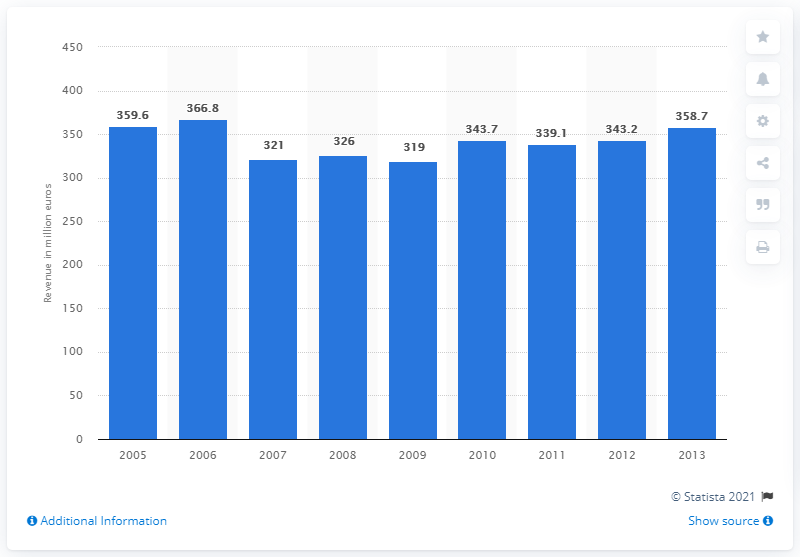Which year marked the lowest revenue, and can you estimate the amount? According to the bar chart, the lowest revenue was in the year 2009, with an estimated amount of roughly 319 million euros.  Can you explain how this sort of financial data might be useful? Financial data like this is crucial for stakeholders, including investors, analysts, and company management. It helps in assessing a company's financial health, making informed investment decisions, and strategically planning for future growth or cost management. 